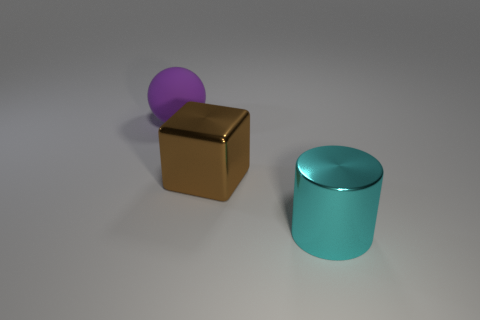There is a object that is left of the big cyan shiny thing and to the right of the large purple sphere; what size is it?
Make the answer very short. Large. What number of other purple objects are the same shape as the large purple object?
Provide a short and direct response. 0. What is the material of the purple object?
Offer a very short reply. Rubber. Is the shape of the brown metallic thing the same as the cyan shiny thing?
Make the answer very short. No. Is there a big block that has the same material as the cylinder?
Provide a short and direct response. Yes. What is the color of the large thing that is in front of the big rubber ball and behind the metallic cylinder?
Make the answer very short. Brown. There is a big object to the left of the cube; what is it made of?
Provide a succinct answer. Rubber. Are there any other brown things that have the same shape as the big brown metal object?
Provide a succinct answer. No. What number of other objects are there of the same shape as the big purple object?
Keep it short and to the point. 0. There is a purple rubber thing; is its shape the same as the big shiny thing right of the brown metal cube?
Offer a very short reply. No. 